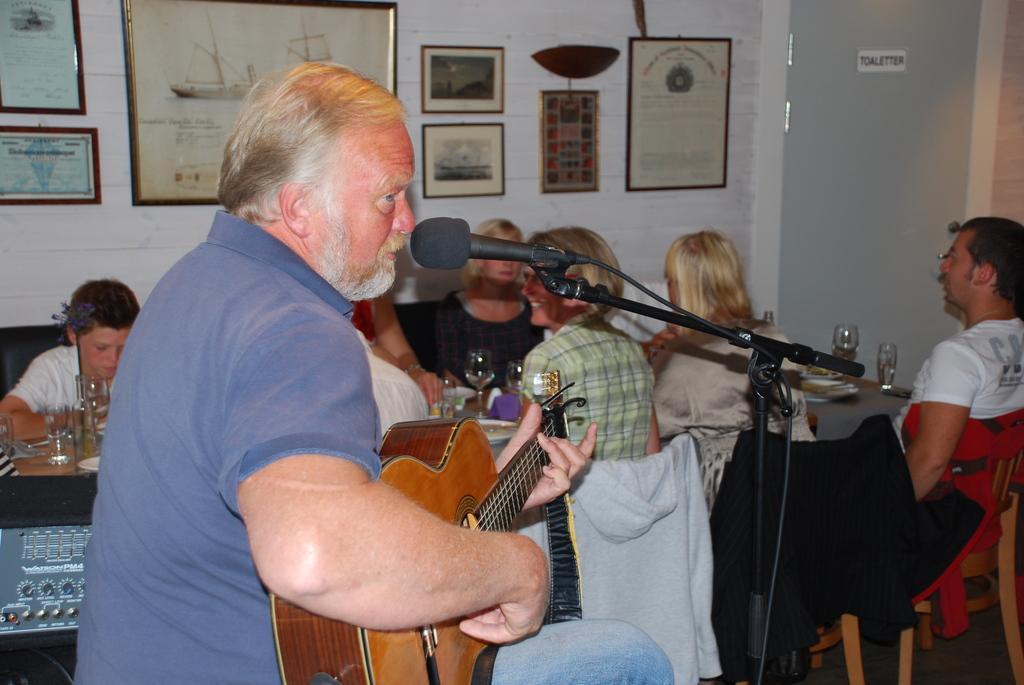Please provide a concise description of this image. here in this picture we can see a person holding guitar in his hand with a microphone in front of he,here we can also see some persons sitting on a chair with a dining table in front of them with different equipments such as glasses,plates e. t. c,here on the wall wwe can see different frames which is beside the dining table. 